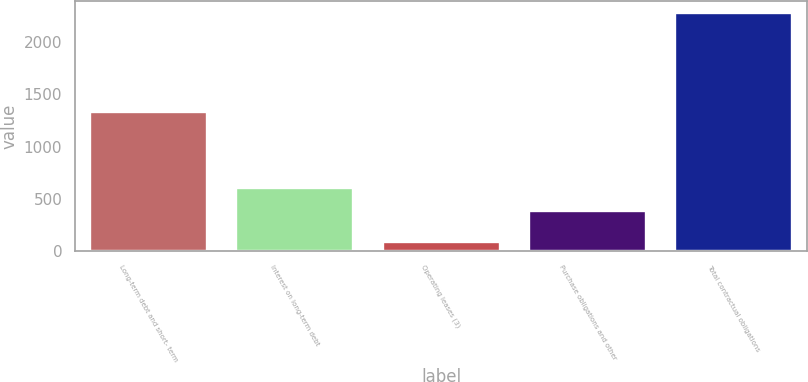Convert chart. <chart><loc_0><loc_0><loc_500><loc_500><bar_chart><fcel>Long-term debt and short- term<fcel>Interest on long-term debt<fcel>Operating leases (3)<fcel>Purchase obligations and other<fcel>Total contractual obligations<nl><fcel>1333<fcel>600.7<fcel>87<fcel>381<fcel>2284<nl></chart> 